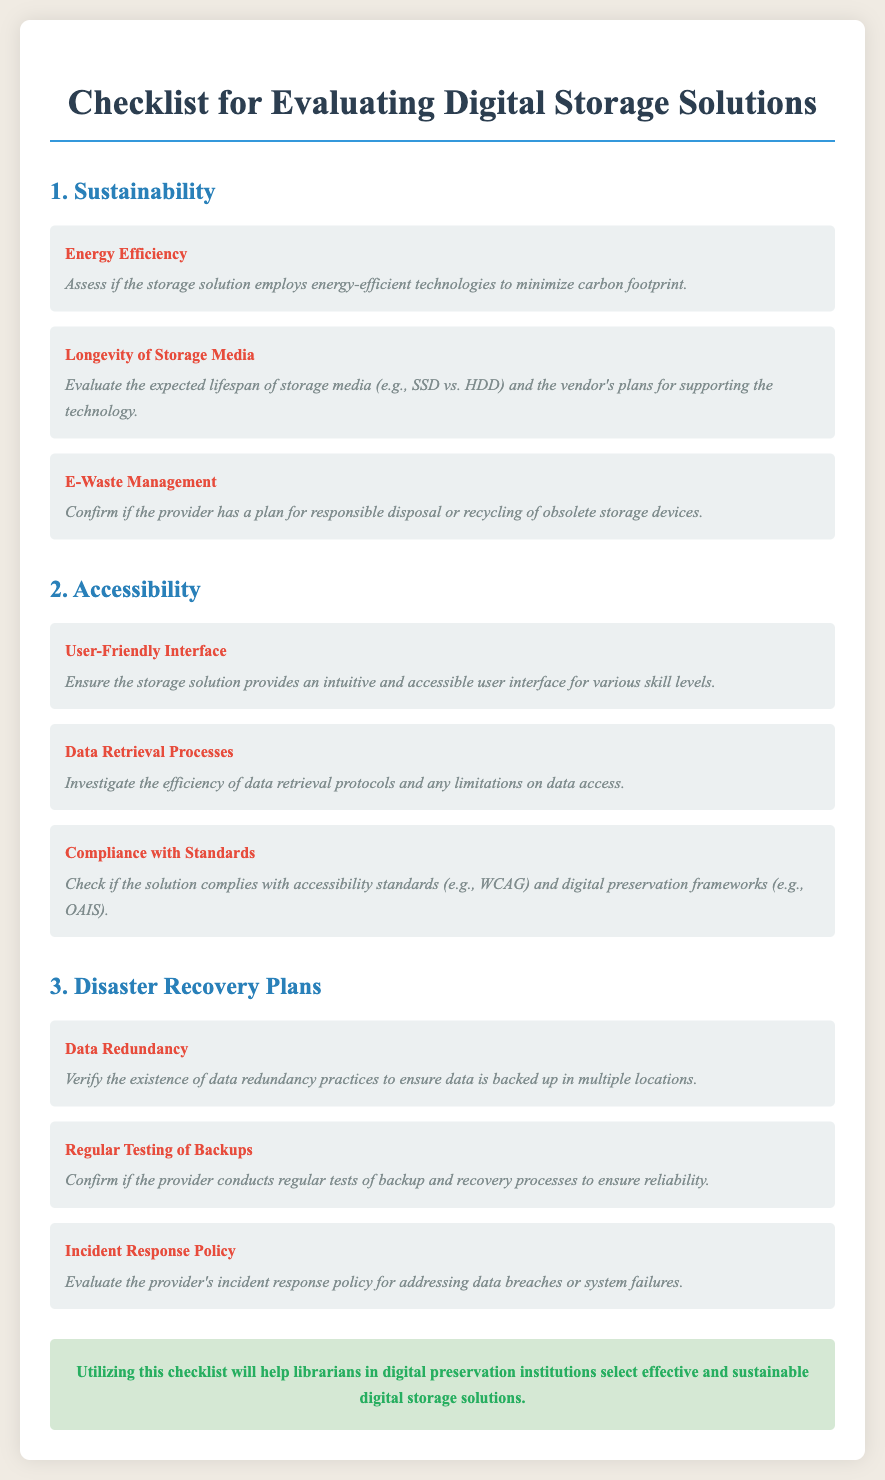What is the first category in the checklist? The first category listed in the checklist is "Sustainability."
Answer: Sustainability What is one criterion for evaluating disaster recovery plans? One criterion mentioned for evaluating disaster recovery plans is "Data Redundancy."
Answer: Data Redundancy How many criteria are listed under accessibility? There are three criteria listed under accessibility.
Answer: 3 What does the checklist recommend checking regarding e-waste? The checklist recommends confirming if the provider has a plan for responsible disposal or recycling of obsolete storage devices.
Answer: Responsible disposal or recycling What criteria assesses the lifespan of storage media? The criterion that assesses the lifespan of storage media is "Longevity of Storage Media."
Answer: Longevity of Storage Media What does the conclusion suggest about the checklist? The conclusion suggests that utilizing the checklist will help librarians select effective and sustainable digital storage solutions.
Answer: Effective and sustainable digital storage solutions What is the purpose of the "Incident Response Policy" criterion? The purpose of the "Incident Response Policy" criterion is to evaluate the provider's policy for addressing data breaches or system failures.
Answer: Addressing data breaches or system failures Is there a criterion that checks for compliance with accessibility standards? Yes, there is a criterion specifically for compliance with accessibility standards, titled "Compliance with Standards."
Answer: Compliance with Standards 